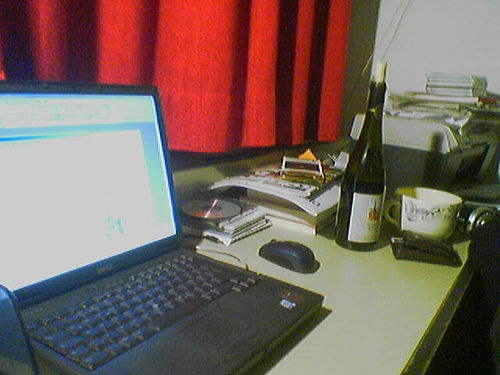Describe the objects in this image and their specific colors. I can see laptop in maroon, lightgray, blue, gray, and black tones, bottle in maroon, black, darkgray, darkgreen, and gray tones, cup in maroon, darkgray, darkgreen, black, and olive tones, mouse in maroon, black, gray, darkgreen, and purple tones, and book in maroon, lightgray, darkgray, and black tones in this image. 